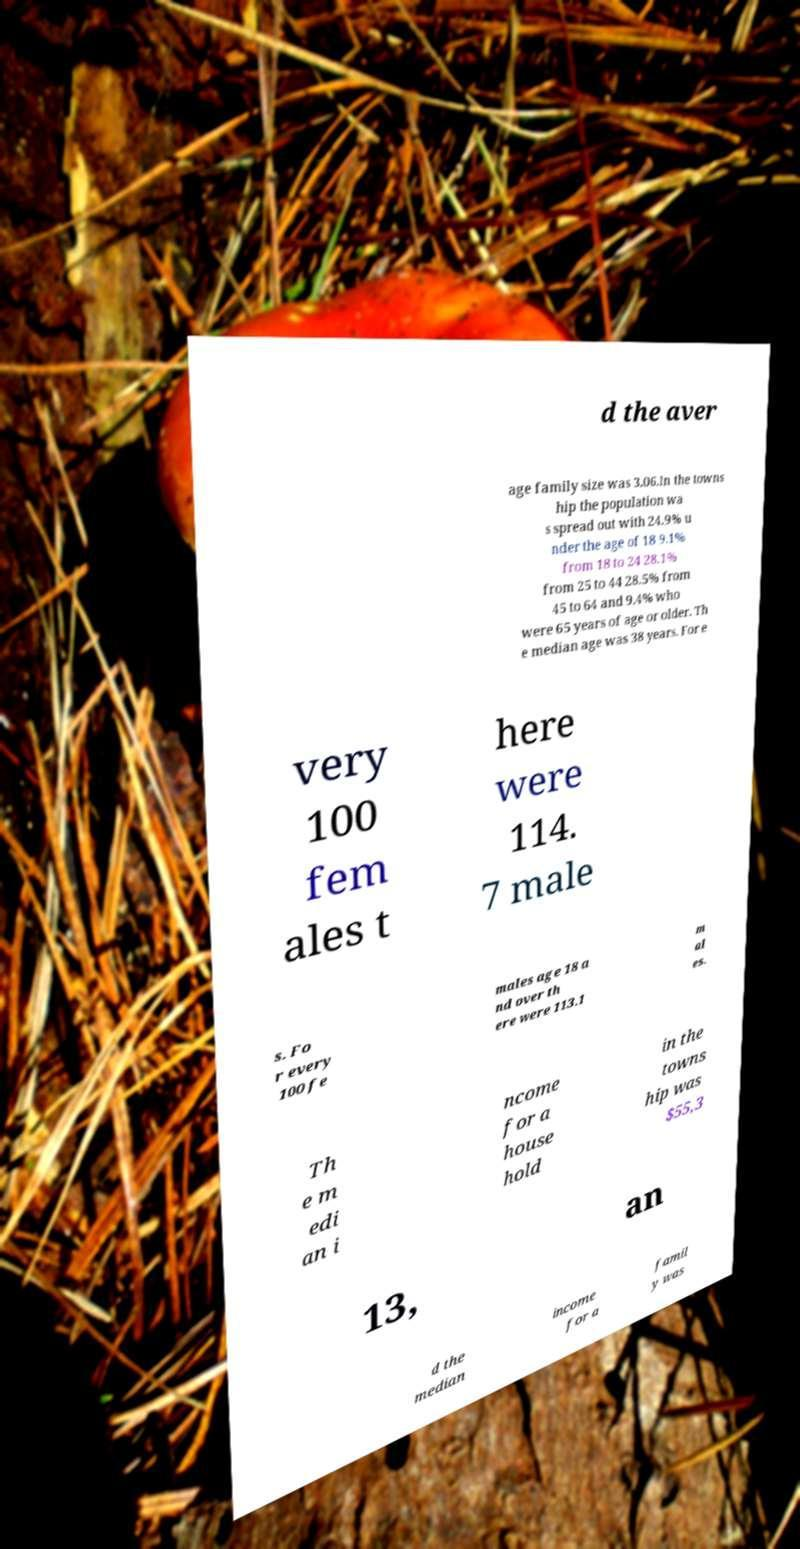Can you read and provide the text displayed in the image?This photo seems to have some interesting text. Can you extract and type it out for me? d the aver age family size was 3.06.In the towns hip the population wa s spread out with 24.9% u nder the age of 18 9.1% from 18 to 24 28.1% from 25 to 44 28.5% from 45 to 64 and 9.4% who were 65 years of age or older. Th e median age was 38 years. For e very 100 fem ales t here were 114. 7 male s. Fo r every 100 fe males age 18 a nd over th ere were 113.1 m al es. Th e m edi an i ncome for a house hold in the towns hip was $55,3 13, an d the median income for a famil y was 